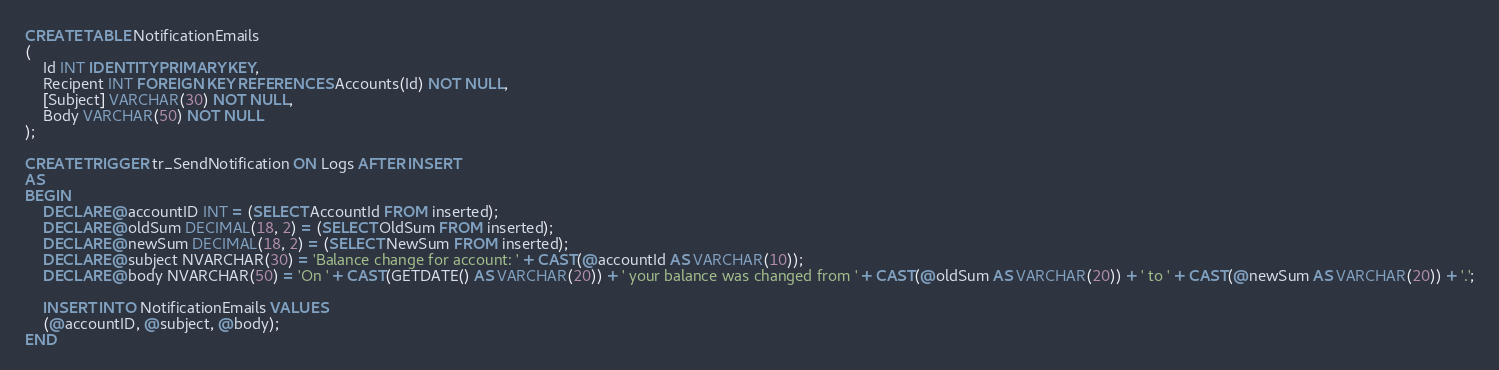<code> <loc_0><loc_0><loc_500><loc_500><_SQL_>CREATE TABLE NotificationEmails
(
	Id INT IDENTITY PRIMARY KEY,
	Recipent INT FOREIGN KEY REFERENCES Accounts(Id) NOT NULL,
	[Subject] VARCHAR(30) NOT NULL,
	Body VARCHAR(50) NOT NULL
);

CREATE TRIGGER tr_SendNotification ON Logs AFTER INSERT
AS
BEGIN
	DECLARE @accountID INT = (SELECT AccountId FROM inserted);
	DECLARE @oldSum DECIMAL(18, 2) = (SELECT OldSum FROM inserted);
	DECLARE @newSum DECIMAL(18, 2) = (SELECT NewSum FROM inserted);
	DECLARE @subject NVARCHAR(30) = 'Balance change for account: ' + CAST(@accountId AS VARCHAR(10));
	DECLARE @body NVARCHAR(50) = 'On ' + CAST(GETDATE() AS VARCHAR(20)) + ' your balance was changed from ' + CAST(@oldSum AS VARCHAR(20)) + ' to ' + CAST(@newSum AS VARCHAR(20)) + '.';

	INSERT INTO NotificationEmails VALUES
	(@accountID, @subject, @body);
END</code> 